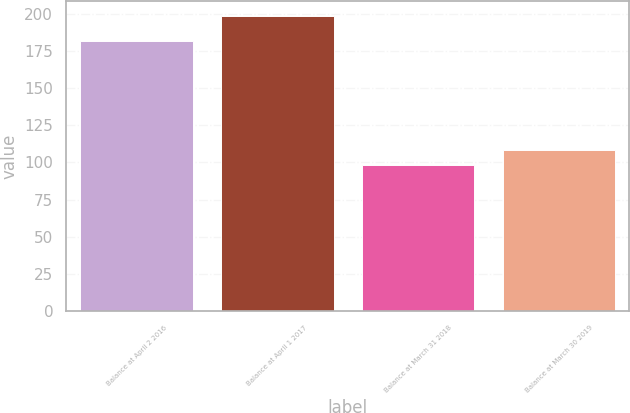<chart> <loc_0><loc_0><loc_500><loc_500><bar_chart><fcel>Balance at April 2 2016<fcel>Balance at April 1 2017<fcel>Balance at March 31 2018<fcel>Balance at March 30 2019<nl><fcel>181.5<fcel>198.4<fcel>98.5<fcel>108.49<nl></chart> 